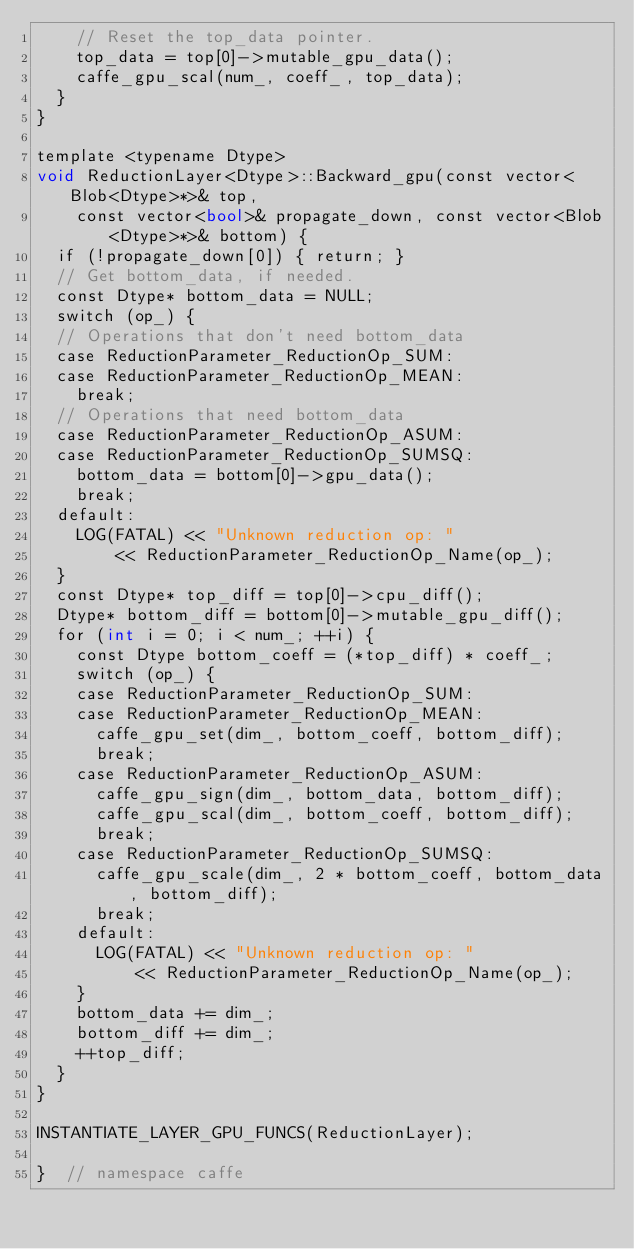Convert code to text. <code><loc_0><loc_0><loc_500><loc_500><_Cuda_>    // Reset the top_data pointer.
    top_data = top[0]->mutable_gpu_data();
    caffe_gpu_scal(num_, coeff_, top_data);
  }
}

template <typename Dtype>
void ReductionLayer<Dtype>::Backward_gpu(const vector<Blob<Dtype>*>& top,
    const vector<bool>& propagate_down, const vector<Blob<Dtype>*>& bottom) {
  if (!propagate_down[0]) { return; }
  // Get bottom_data, if needed.
  const Dtype* bottom_data = NULL;
  switch (op_) {
  // Operations that don't need bottom_data
  case ReductionParameter_ReductionOp_SUM:
  case ReductionParameter_ReductionOp_MEAN:
    break;
  // Operations that need bottom_data
  case ReductionParameter_ReductionOp_ASUM:
  case ReductionParameter_ReductionOp_SUMSQ:
    bottom_data = bottom[0]->gpu_data();
    break;
  default:
    LOG(FATAL) << "Unknown reduction op: "
        << ReductionParameter_ReductionOp_Name(op_);
  }
  const Dtype* top_diff = top[0]->cpu_diff();
  Dtype* bottom_diff = bottom[0]->mutable_gpu_diff();
  for (int i = 0; i < num_; ++i) {
    const Dtype bottom_coeff = (*top_diff) * coeff_;
    switch (op_) {
    case ReductionParameter_ReductionOp_SUM:
    case ReductionParameter_ReductionOp_MEAN:
      caffe_gpu_set(dim_, bottom_coeff, bottom_diff);
      break;
    case ReductionParameter_ReductionOp_ASUM:
      caffe_gpu_sign(dim_, bottom_data, bottom_diff);
      caffe_gpu_scal(dim_, bottom_coeff, bottom_diff);
      break;
    case ReductionParameter_ReductionOp_SUMSQ:
      caffe_gpu_scale(dim_, 2 * bottom_coeff, bottom_data, bottom_diff);
      break;
    default:
      LOG(FATAL) << "Unknown reduction op: "
          << ReductionParameter_ReductionOp_Name(op_);
    }
    bottom_data += dim_;
    bottom_diff += dim_;
    ++top_diff;
  }
}

INSTANTIATE_LAYER_GPU_FUNCS(ReductionLayer);

}  // namespace caffe
</code> 